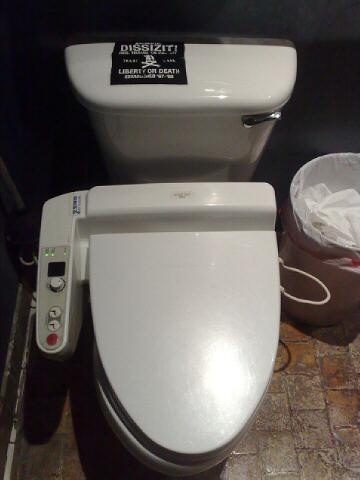Describe the objects in this image and their specific colors. I can see a toilet in black, darkgray, gray, and lightgray tones in this image. 